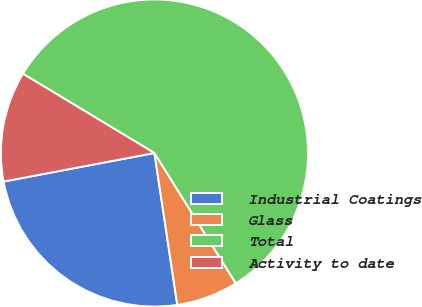<chart> <loc_0><loc_0><loc_500><loc_500><pie_chart><fcel>Industrial Coatings<fcel>Glass<fcel>Total<fcel>Activity to date<nl><fcel>24.4%<fcel>6.51%<fcel>57.48%<fcel>11.61%<nl></chart> 